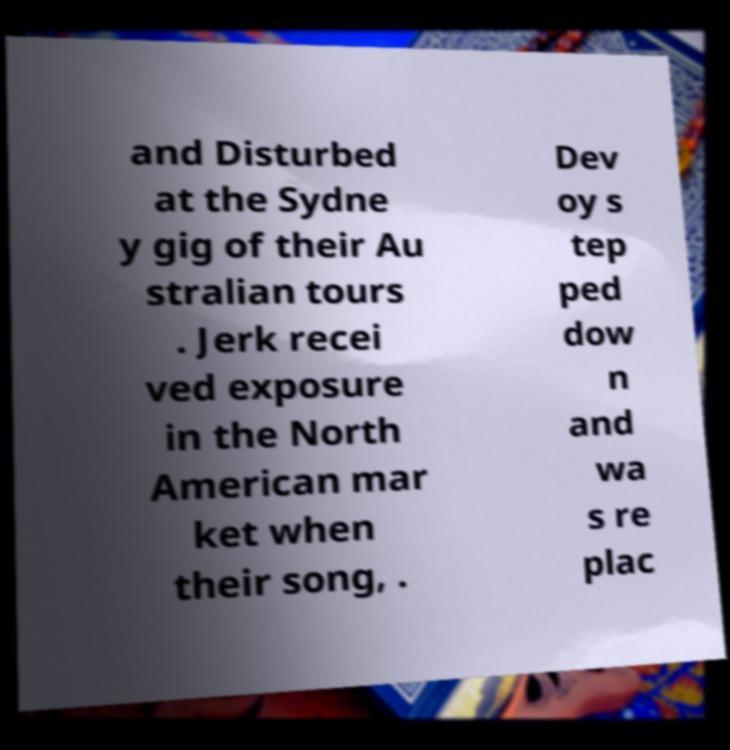Could you assist in decoding the text presented in this image and type it out clearly? and Disturbed at the Sydne y gig of their Au stralian tours . Jerk recei ved exposure in the North American mar ket when their song, . Dev oy s tep ped dow n and wa s re plac 